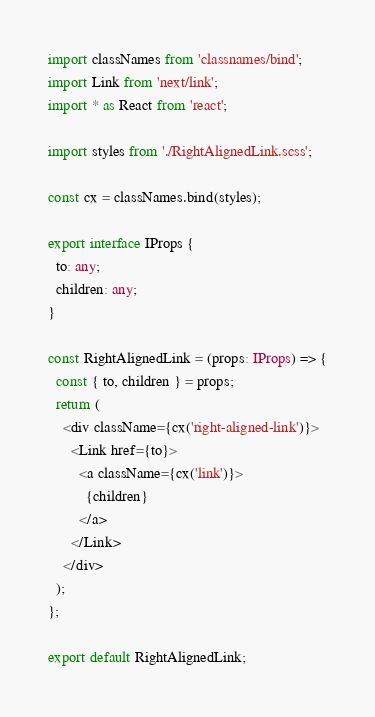Convert code to text. <code><loc_0><loc_0><loc_500><loc_500><_TypeScript_>import classNames from 'classnames/bind';
import Link from 'next/link';
import * as React from 'react';

import styles from './RightAlignedLink.scss';

const cx = classNames.bind(styles);

export interface IProps {
  to: any;
  children: any;
}

const RightAlignedLink = (props: IProps) => {
  const { to, children } = props;
  return (
    <div className={cx('right-aligned-link')}>
      <Link href={to}>
        <a className={cx('link')}>
          {children}
        </a>
      </Link>
    </div>
  );
};

export default RightAlignedLink;</code> 